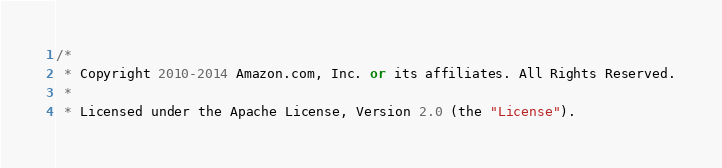Convert code to text. <code><loc_0><loc_0><loc_500><loc_500><_C#_>/*
 * Copyright 2010-2014 Amazon.com, Inc. or its affiliates. All Rights Reserved.
 * 
 * Licensed under the Apache License, Version 2.0 (the "License").</code> 